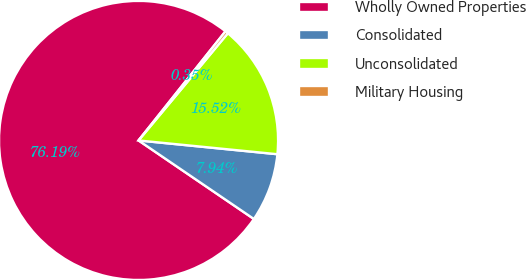Convert chart. <chart><loc_0><loc_0><loc_500><loc_500><pie_chart><fcel>Wholly Owned Properties<fcel>Consolidated<fcel>Unconsolidated<fcel>Military Housing<nl><fcel>76.19%<fcel>7.94%<fcel>15.52%<fcel>0.35%<nl></chart> 